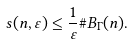<formula> <loc_0><loc_0><loc_500><loc_500>s ( n , \varepsilon ) \leq \frac { 1 } { \varepsilon } \# B _ { \Gamma } ( n ) .</formula> 